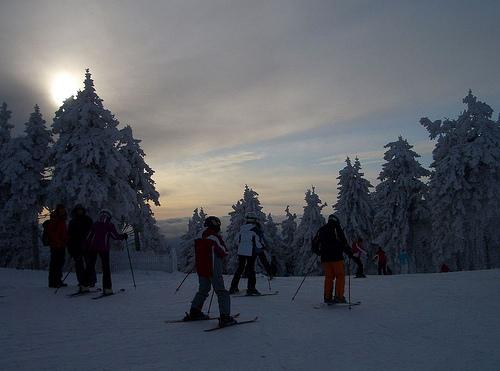Is it cloudy?
Give a very brief answer. Yes. How many people are skiing?
Quick response, please. 5. What is the man holding?
Short answer required. Ski poles. Is it night or day?
Answer briefly. Night. How many skiers are there?
Quick response, please. 5. Is this photo from decades past?
Short answer required. No. Is the man in the front right skiing at the moment?
Quick response, please. Yes. What are the people looking at?
Short answer required. Trees. How excited are the vacationers to see this mountain?
Be succinct. Very. Is that a parking lot?
Write a very short answer. No. What sport is being played?
Concise answer only. Skiing. What sport is the boy engaging in?
Quick response, please. Skiing. What time of day is it?
Short answer required. Evening. Is there a way this photo could have been composed so as to avoid back-lighting?
Give a very brief answer. Yes. How many types of transportation items are in this picture?
Be succinct. 1. What is behind that man?
Short answer required. Trees. What kind of trees are present in the background of this photograph?
Concise answer only. Pine. Are the trees snow covered?
Keep it brief. Yes. What season do you think this scene is set in?
Answer briefly. Winter. 